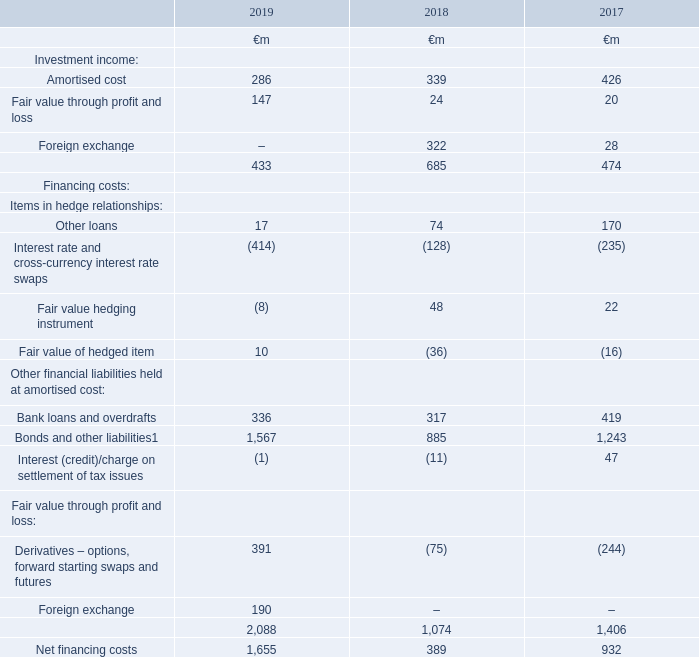5. Investment income and financing costs
Investment income comprises interest received from short-term investments and other receivables as well as certain foreign exchange movements. Financing costs mainly arise from interest due on bonds and commercial paper issued, bank loans and the results of hedging transactions used to manage foreign exchange and interest rate movements
Note: 1 Includes €305 million (2018: €187 million; 2017: €272 million) of interest on foreign exchange derivatives.
Which financial years' information is shown in the table? 2017, 2018, 2019. What does investment income comprise of? Interest received from short-term investments and other receivables as well as certain foreign exchange movements. How much is the 2019 amortised cost under investment income?
Answer scale should be: million. 286. How much is the 2019 bonds and other liabilities, excluding the interest on foreign exchange derivatives?
Answer scale should be: million. 1,567-305 
Answer: 1262. How much is the 2018 bonds and other liabilities, excluding the interest on foreign exchange derivatives?
Answer scale should be: million. 885-187
Answer: 698. How much is the 2017 bonds and other liabilities, excluding the interest on foreign exchange derivatives?
Answer scale should be: million. 1,243-272
Answer: 971. 